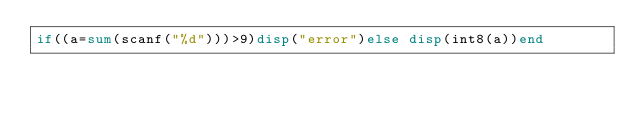Convert code to text. <code><loc_0><loc_0><loc_500><loc_500><_Octave_>if((a=sum(scanf("%d")))>9)disp("error")else disp(int8(a))end</code> 